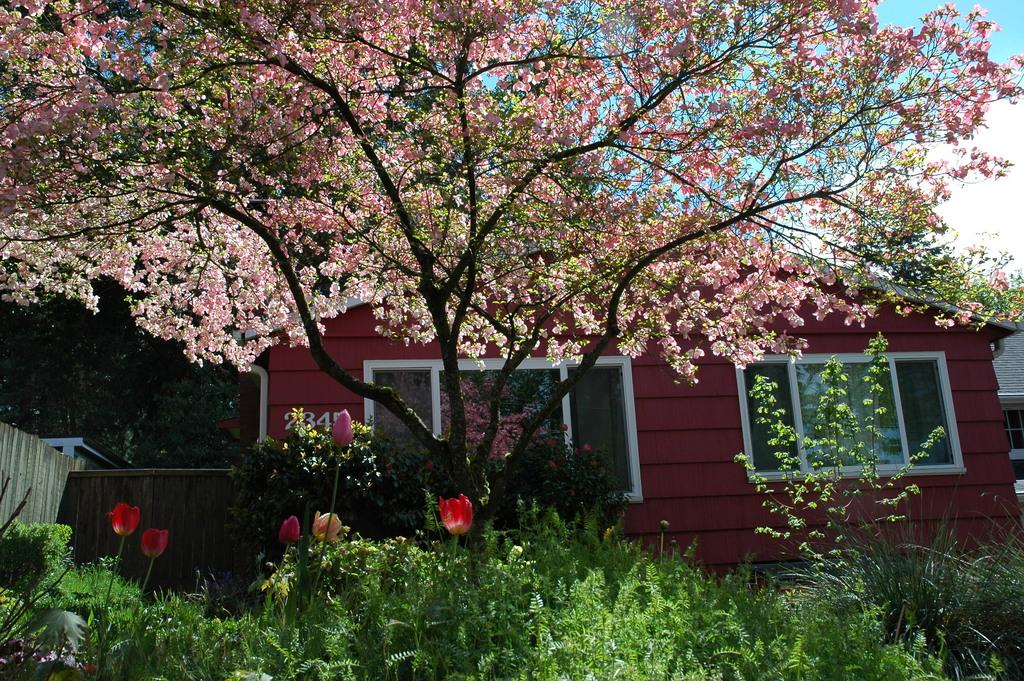What type of structure is in the image? There is a house in the image. Can you describe any specific details about the house? The house has the number "2345" on it. What other natural elements can be seen in the image? There is a tree, plants, and flowers in the image. What is visible in the background of the image? The sky is visible in the image. What is the tendency of the flowers to smile in the image? The flowers do not have the ability to smile, as they are inanimate objects. 